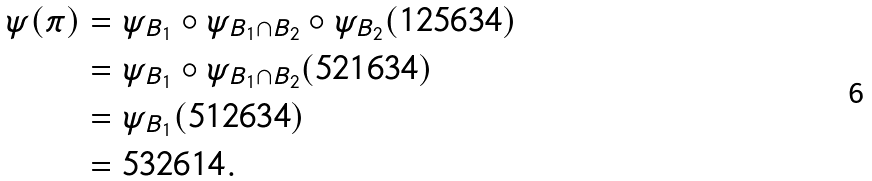Convert formula to latex. <formula><loc_0><loc_0><loc_500><loc_500>\psi ( \pi ) & = \psi _ { B _ { 1 } } \circ \psi _ { B _ { 1 } \cap B _ { 2 } } \circ \psi _ { B _ { 2 } } ( 1 2 5 6 3 4 ) \\ & = \psi _ { B _ { 1 } } \circ \psi _ { B _ { 1 } \cap B _ { 2 } } ( 5 2 1 6 3 4 ) \\ & = \psi _ { B _ { 1 } } ( 5 1 2 6 3 4 ) \\ & = 5 3 2 6 1 4 .</formula> 